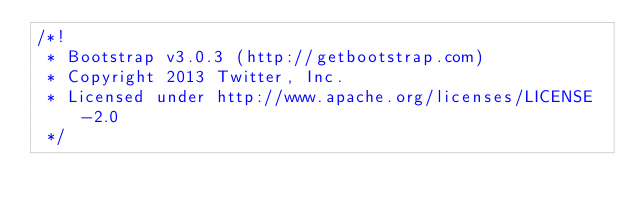Convert code to text. <code><loc_0><loc_0><loc_500><loc_500><_CSS_>/*!
 * Bootstrap v3.0.3 (http://getbootstrap.com)
 * Copyright 2013 Twitter, Inc.
 * Licensed under http://www.apache.org/licenses/LICENSE-2.0
 */
</code> 